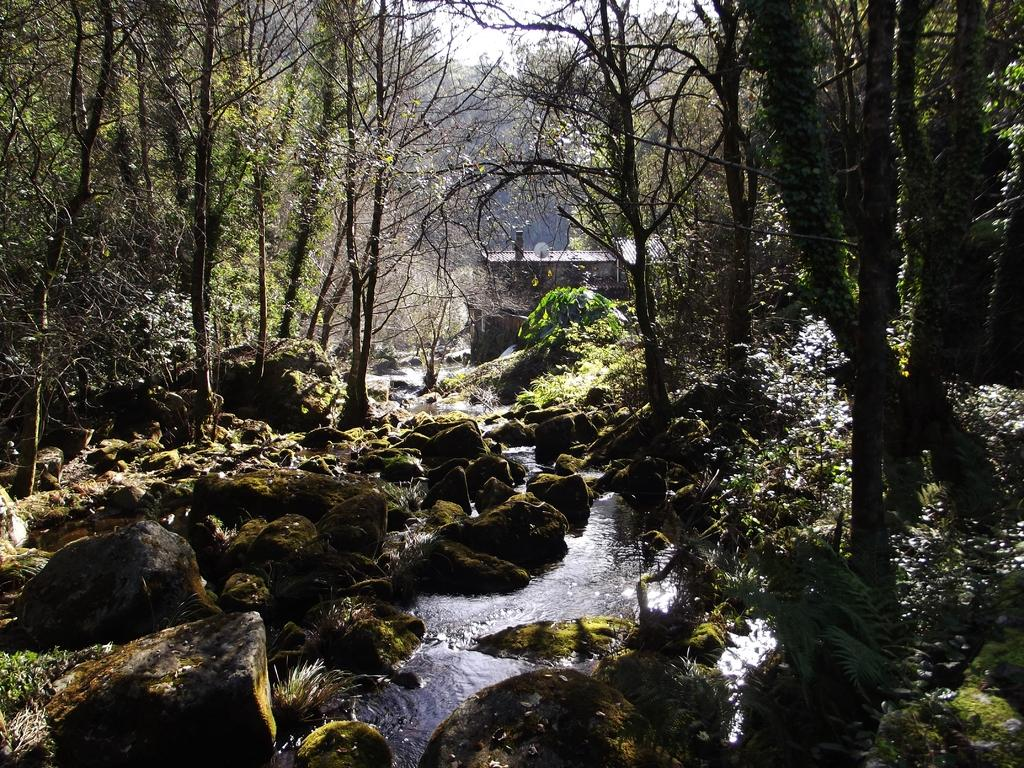What type of natural elements can be seen in the image? There are trees and rocks visible in the image. What is happening with the water in the image? Water is flowing in the middle of the rocks. Can you describe the rock structure in the image? There is a rock structure in the image. What is visible in the background of the image? The sky is visible in the background of the image. What type of quill is being used to write on the rocks in the image? There is no quill or writing present in the image; it features natural elements such as trees, rocks, and water. What is the limit of the water flow in the image? The image does not provide information about the limit of the water flow; it only shows water flowing in the middle of the rocks. 